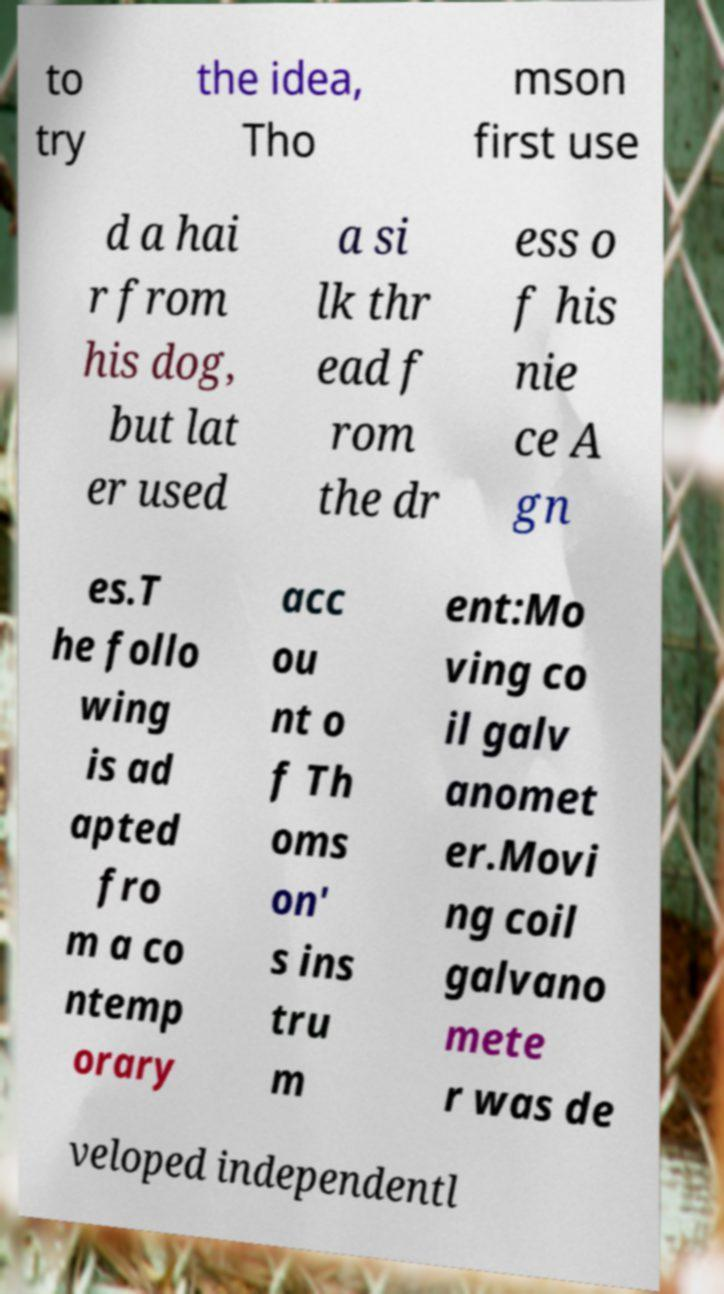What messages or text are displayed in this image? I need them in a readable, typed format. to try the idea, Tho mson first use d a hai r from his dog, but lat er used a si lk thr ead f rom the dr ess o f his nie ce A gn es.T he follo wing is ad apted fro m a co ntemp orary acc ou nt o f Th oms on' s ins tru m ent:Mo ving co il galv anomet er.Movi ng coil galvano mete r was de veloped independentl 